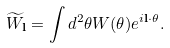<formula> <loc_0><loc_0><loc_500><loc_500>\widetilde { W } _ { \mathbf l } = \int d ^ { 2 } \theta W ( { \mathbf \theta } ) e ^ { i { \mathbf l \cdot \theta } } .</formula> 